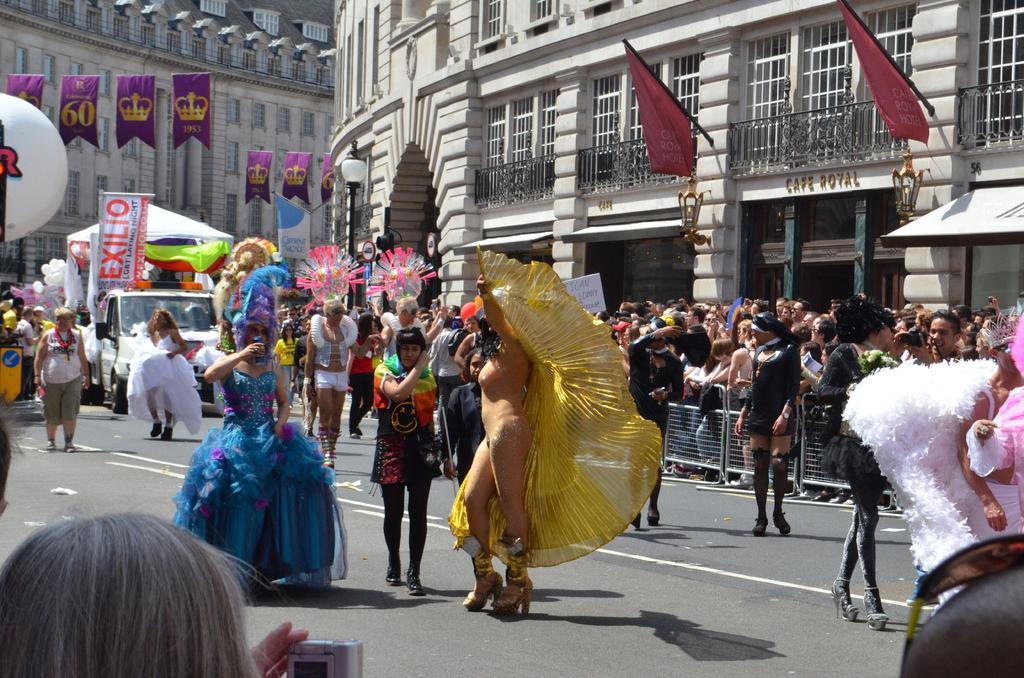Describe this image in one or two sentences. In this image I see number of people in which few of them are wearing costumes and I see a vehicle over here and I see the banner over here on which there is something written and I see the flags over here and I see few clothes on which there are numbers and crowns on it and I see the buildings and I see a person over here who is holding a camera and I see the fencing over here. 